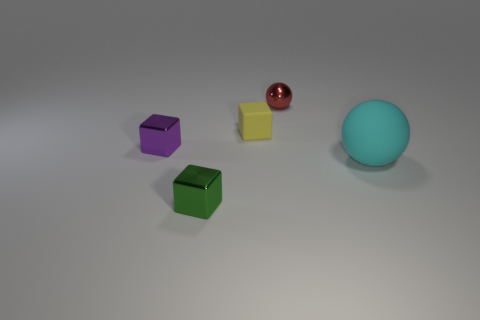What is the shape of the small green shiny thing?
Ensure brevity in your answer.  Cube. Is there a blue matte sphere of the same size as the purple cube?
Your response must be concise. No. What material is the purple object that is the same size as the yellow matte block?
Keep it short and to the point. Metal. Is there a red metal object that has the same shape as the tiny green object?
Make the answer very short. No. What shape is the object that is on the right side of the tiny metal sphere?
Your answer should be very brief. Sphere. What number of red metal balls are there?
Make the answer very short. 1. What color is the small block that is made of the same material as the big cyan object?
Offer a very short reply. Yellow. How many large things are purple blocks or cyan cylinders?
Ensure brevity in your answer.  0. How many matte blocks are to the left of the small metal ball?
Your response must be concise. 1. What color is the rubber object that is the same shape as the red metallic thing?
Ensure brevity in your answer.  Cyan. 